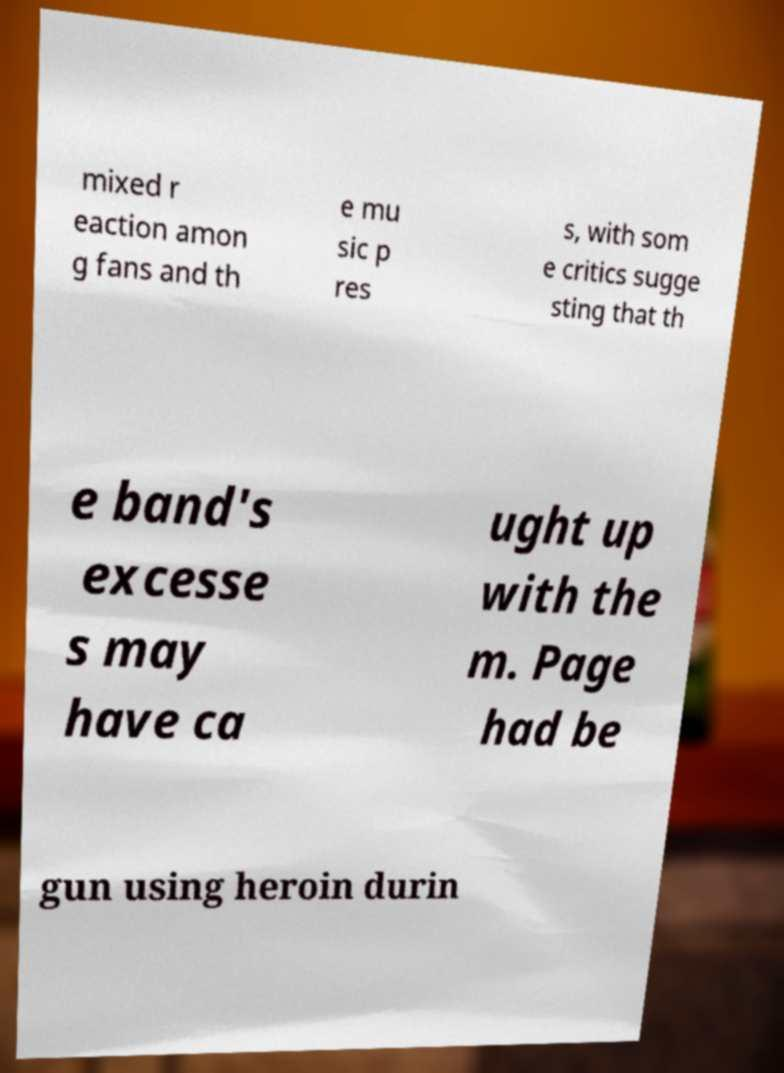Please identify and transcribe the text found in this image. mixed r eaction amon g fans and th e mu sic p res s, with som e critics sugge sting that th e band's excesse s may have ca ught up with the m. Page had be gun using heroin durin 